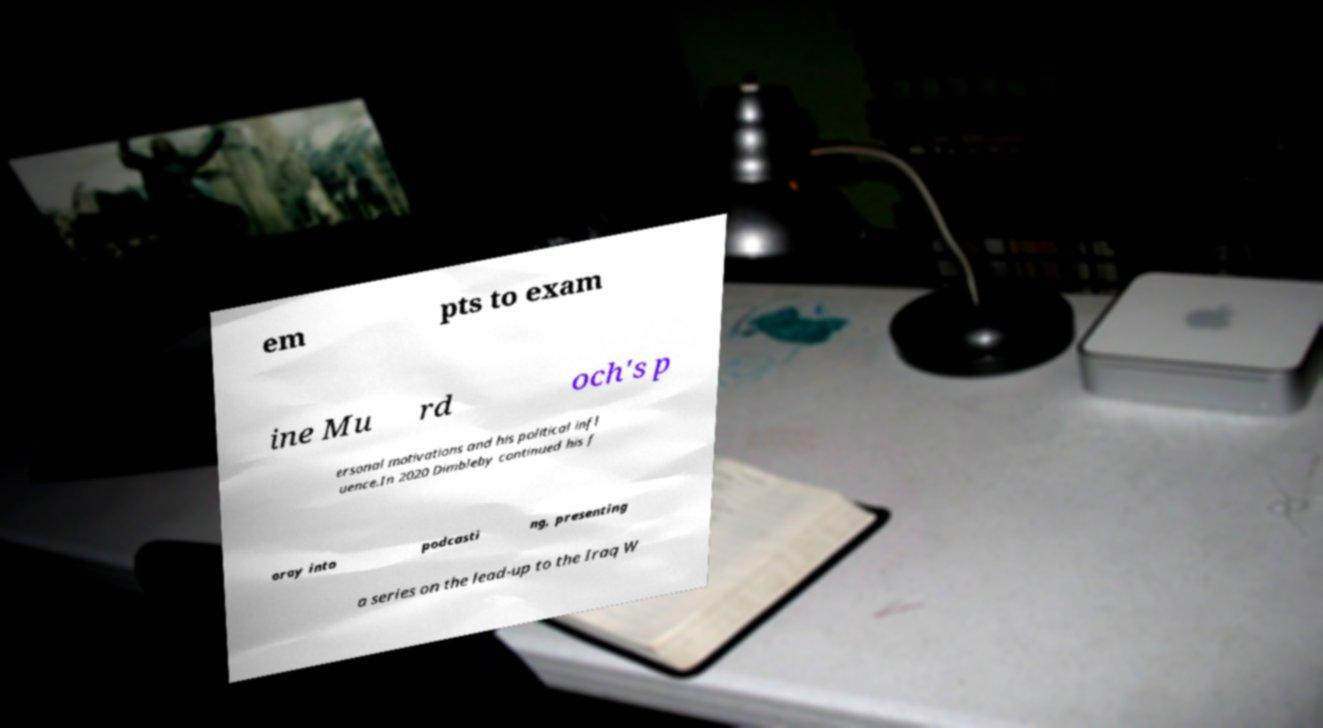Can you read and provide the text displayed in the image?This photo seems to have some interesting text. Can you extract and type it out for me? em pts to exam ine Mu rd och's p ersonal motivations and his political infl uence.In 2020 Dimbleby continued his f oray into podcasti ng, presenting a series on the lead-up to the Iraq W 